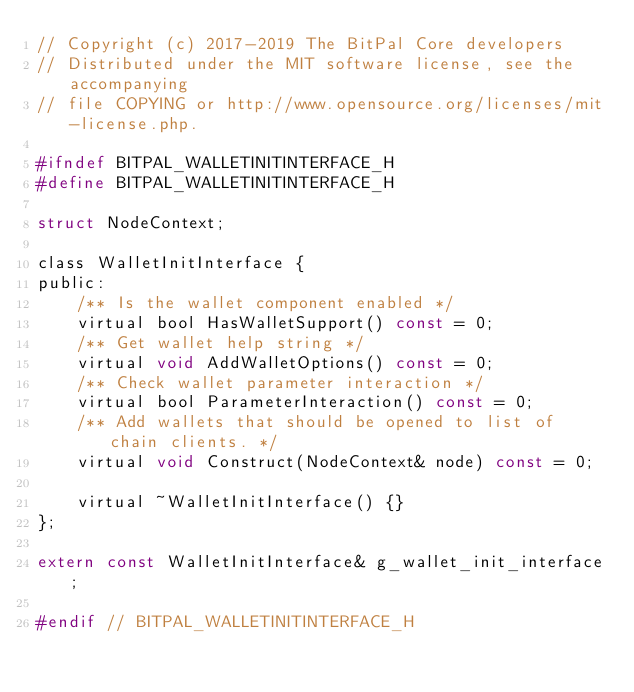<code> <loc_0><loc_0><loc_500><loc_500><_C_>// Copyright (c) 2017-2019 The BitPal Core developers
// Distributed under the MIT software license, see the accompanying
// file COPYING or http://www.opensource.org/licenses/mit-license.php.

#ifndef BITPAL_WALLETINITINTERFACE_H
#define BITPAL_WALLETINITINTERFACE_H

struct NodeContext;

class WalletInitInterface {
public:
    /** Is the wallet component enabled */
    virtual bool HasWalletSupport() const = 0;
    /** Get wallet help string */
    virtual void AddWalletOptions() const = 0;
    /** Check wallet parameter interaction */
    virtual bool ParameterInteraction() const = 0;
    /** Add wallets that should be opened to list of chain clients. */
    virtual void Construct(NodeContext& node) const = 0;

    virtual ~WalletInitInterface() {}
};

extern const WalletInitInterface& g_wallet_init_interface;

#endif // BITPAL_WALLETINITINTERFACE_H
</code> 